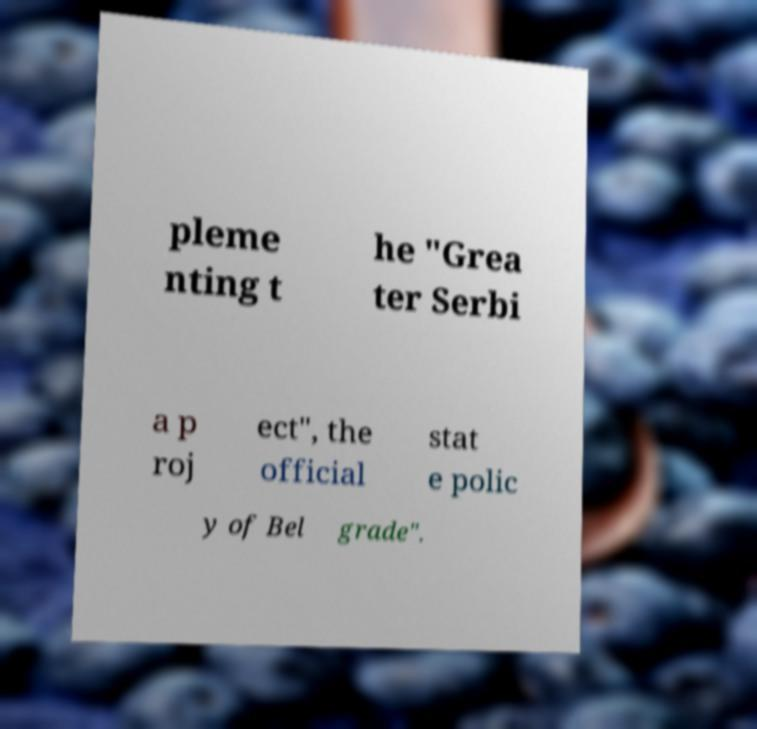Could you extract and type out the text from this image? pleme nting t he "Grea ter Serbi a p roj ect", the official stat e polic y of Bel grade". 